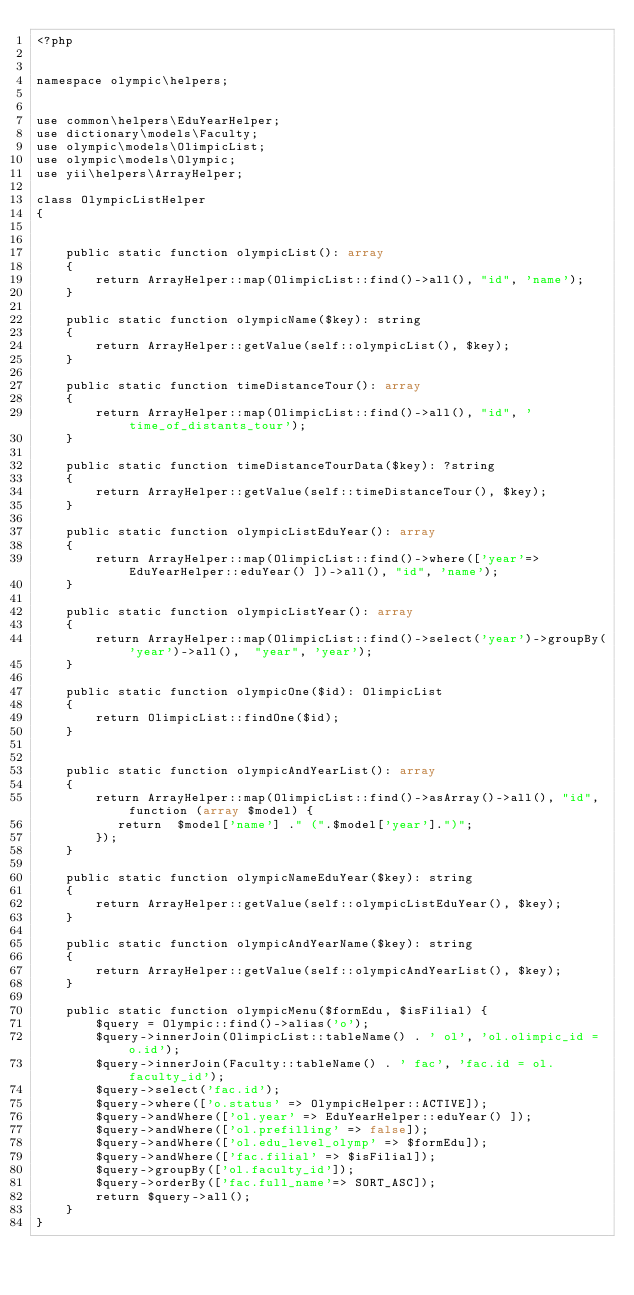<code> <loc_0><loc_0><loc_500><loc_500><_PHP_><?php


namespace olympic\helpers;


use common\helpers\EduYearHelper;
use dictionary\models\Faculty;
use olympic\models\OlimpicList;
use olympic\models\Olympic;
use yii\helpers\ArrayHelper;

class OlympicListHelper
{


    public static function olympicList(): array
    {
        return ArrayHelper::map(OlimpicList::find()->all(), "id", 'name');
    }

    public static function olympicName($key): string
    {
        return ArrayHelper::getValue(self::olympicList(), $key);
    }

    public static function timeDistanceTour(): array
    {
        return ArrayHelper::map(OlimpicList::find()->all(), "id", 'time_of_distants_tour');
    }

    public static function timeDistanceTourData($key): ?string
    {
        return ArrayHelper::getValue(self::timeDistanceTour(), $key);
    }

    public static function olympicListEduYear(): array
    {
        return ArrayHelper::map(OlimpicList::find()->where(['year'=> EduYearHelper::eduYear() ])->all(), "id", 'name');
    }

    public static function olympicListYear(): array
    {
        return ArrayHelper::map(OlimpicList::find()->select('year')->groupBy('year')->all(),  "year", 'year');
    }

    public static function olympicOne($id): OlimpicList
    {
        return OlimpicList::findOne($id);
    }


    public static function olympicAndYearList(): array
    {
        return ArrayHelper::map(OlimpicList::find()->asArray()->all(), "id", function (array $model) {
           return  $model['name'] ." (".$model['year'].")";
        });
    }

    public static function olympicNameEduYear($key): string
    {
        return ArrayHelper::getValue(self::olympicListEduYear(), $key);
    }

    public static function olympicAndYearName($key): string
    {
        return ArrayHelper::getValue(self::olympicAndYearList(), $key);
    }

    public static function olympicMenu($formEdu, $isFilial) {
        $query = Olympic::find()->alias('o');
        $query->innerJoin(OlimpicList::tableName() . ' ol', 'ol.olimpic_id = o.id');
        $query->innerJoin(Faculty::tableName() . ' fac', 'fac.id = ol.faculty_id');
        $query->select('fac.id');
        $query->where(['o.status' => OlympicHelper::ACTIVE]);
        $query->andWhere(['ol.year' => EduYearHelper::eduYear() ]);
        $query->andWhere(['ol.prefilling' => false]);
        $query->andWhere(['ol.edu_level_olymp' => $formEdu]);
        $query->andWhere(['fac.filial' => $isFilial]);
        $query->groupBy(['ol.faculty_id']);
        $query->orderBy(['fac.full_name'=> SORT_ASC]);
        return $query->all();
    }
}</code> 